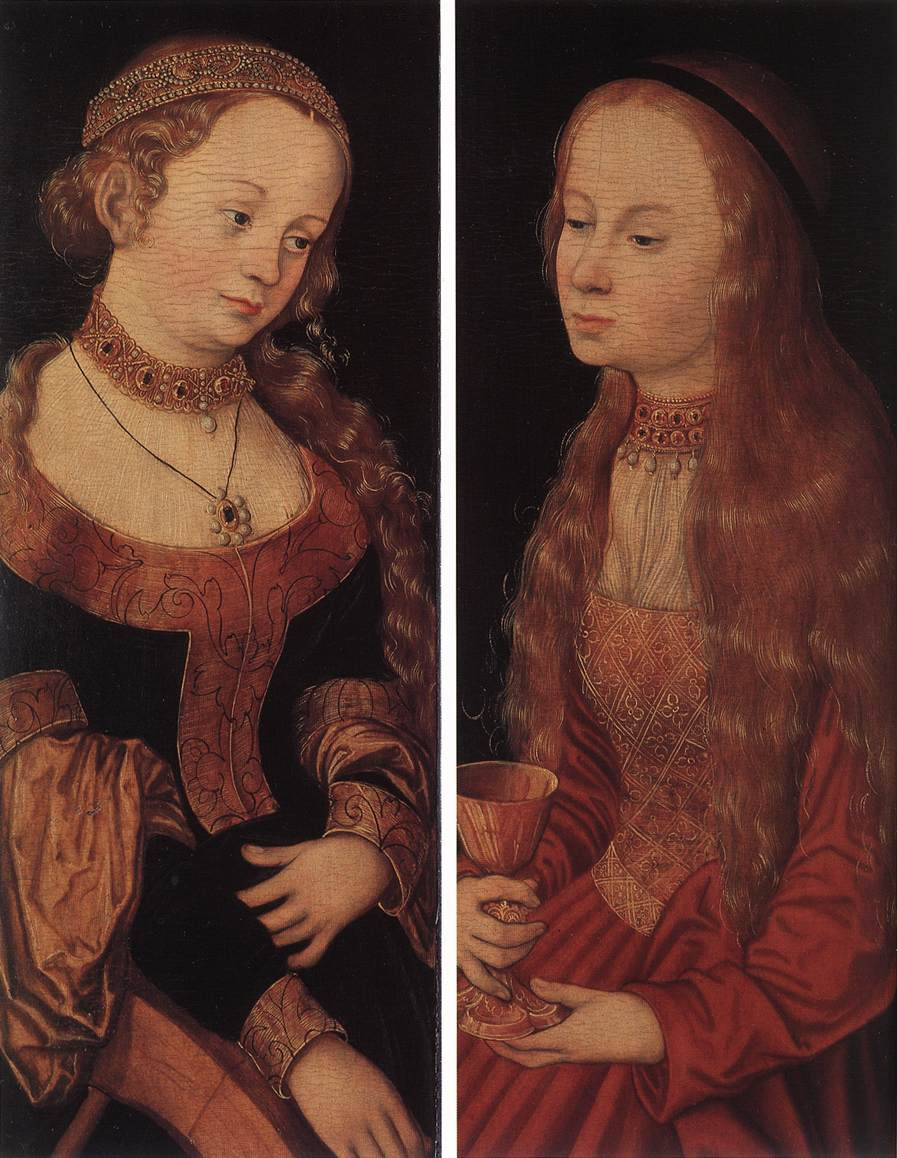Can you tell me more about the symbolism in this painting? Certainly! The two women in this painting are laden with symbolic representations. The book held by the blonde woman can symbolize knowledge, learning, or religious devotion, while the flower may represent beauty or temporal nature. For the red-haired woman, the cup she holds could signify abundance, receptivity, or possibly an invitation to contemplation.

Moreover, their attire and headdresses are not only reflective of their social status but could also be indicative of deeper meanings. The red dress symbolizes love, passion, and power, while the gold embroidery suggests wealth, prestige, and divine favor. The black headdress worn by the red-haired woman could imply mystery, depth, or mourning.

The background's stark darkness helps to place full emphasis on these figures, making their expressions and symbolic objects even more prominent. 